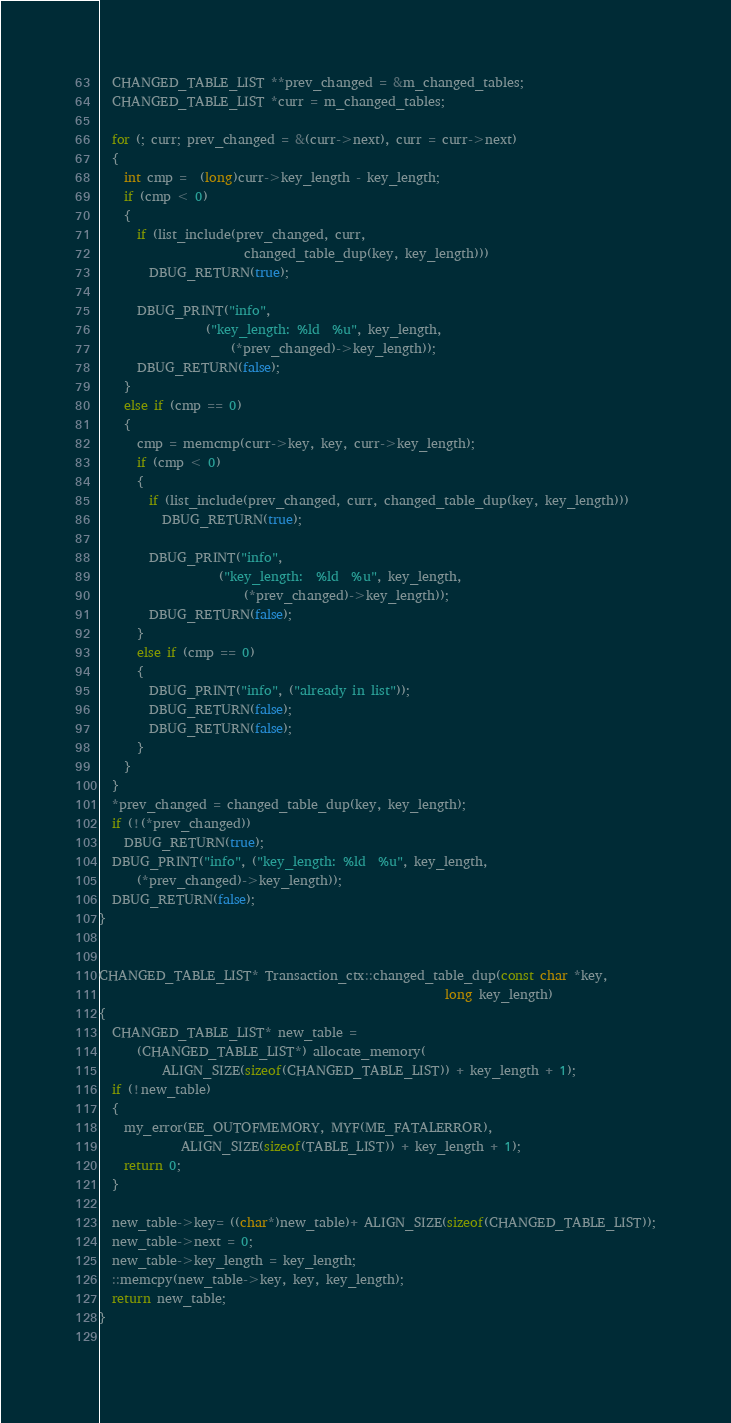Convert code to text. <code><loc_0><loc_0><loc_500><loc_500><_C++_>  CHANGED_TABLE_LIST **prev_changed = &m_changed_tables;
  CHANGED_TABLE_LIST *curr = m_changed_tables;

  for (; curr; prev_changed = &(curr->next), curr = curr->next)
  {
    int cmp =  (long)curr->key_length - key_length;
    if (cmp < 0)
    {
      if (list_include(prev_changed, curr,
                       changed_table_dup(key, key_length)))
        DBUG_RETURN(true);

      DBUG_PRINT("info",
                 ("key_length: %ld  %u", key_length,
                     (*prev_changed)->key_length));
      DBUG_RETURN(false);
    }
    else if (cmp == 0)
    {
      cmp = memcmp(curr->key, key, curr->key_length);
      if (cmp < 0)
      {
        if (list_include(prev_changed, curr, changed_table_dup(key, key_length)))
          DBUG_RETURN(true);

        DBUG_PRINT("info",
                   ("key_length:  %ld  %u", key_length,
                       (*prev_changed)->key_length));
        DBUG_RETURN(false);
      }
      else if (cmp == 0)
      {
        DBUG_PRINT("info", ("already in list"));
        DBUG_RETURN(false);
        DBUG_RETURN(false);
      }
    }
  }
  *prev_changed = changed_table_dup(key, key_length);
  if (!(*prev_changed))
    DBUG_RETURN(true);
  DBUG_PRINT("info", ("key_length: %ld  %u", key_length,
      (*prev_changed)->key_length));
  DBUG_RETURN(false);
}


CHANGED_TABLE_LIST* Transaction_ctx::changed_table_dup(const char *key,
                                                       long key_length)
{
  CHANGED_TABLE_LIST* new_table =
      (CHANGED_TABLE_LIST*) allocate_memory(
          ALIGN_SIZE(sizeof(CHANGED_TABLE_LIST)) + key_length + 1);
  if (!new_table)
  {
    my_error(EE_OUTOFMEMORY, MYF(ME_FATALERROR),
             ALIGN_SIZE(sizeof(TABLE_LIST)) + key_length + 1);
    return 0;
  }

  new_table->key= ((char*)new_table)+ ALIGN_SIZE(sizeof(CHANGED_TABLE_LIST));
  new_table->next = 0;
  new_table->key_length = key_length;
  ::memcpy(new_table->key, key, key_length);
  return new_table;
}
 </code> 